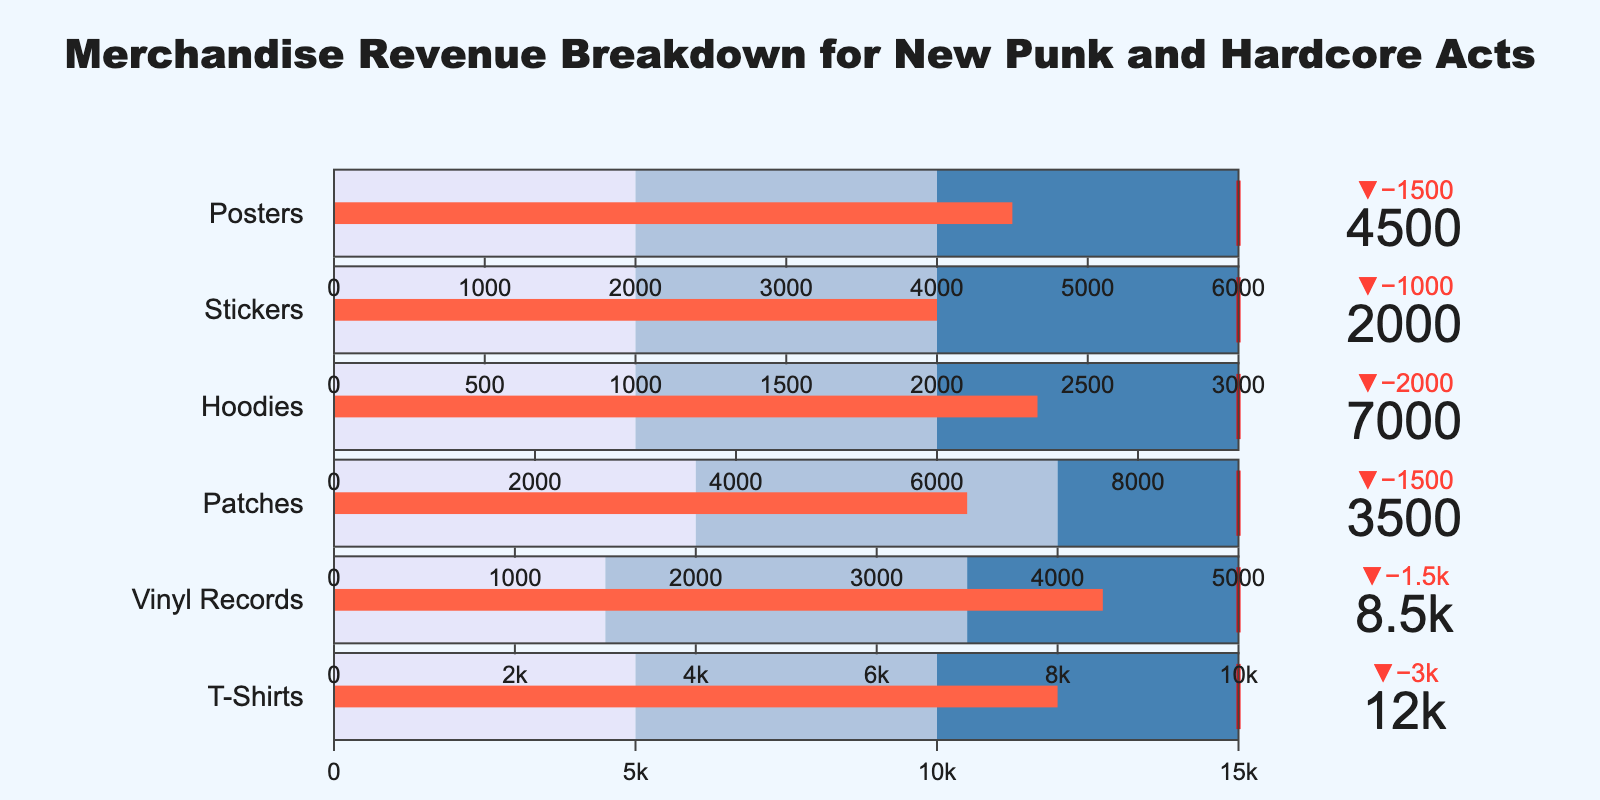What is the title of the figure? The title of the figure is typically placed at the top and is clearly visible. In this case, the title provides an overview of the figure's content.
Answer: Merchandise Revenue Breakdown for New Punk and Hardcore Acts How many revenue categories are there in the figure? To count the number of different categories, refer to the number of rows or groups represented visually in the bullet chart.
Answer: Six Which category has the highest actual revenue? By examining the actual revenue values presented in the bullet sections, we identify the one with the highest numerical value.
Answer: T-Shirts By how much did the actual revenue for Hoodies fall short of the target? Subtract the actual revenue from the target revenue to determine the shortfall. For Hoodies, it is calculated as 9000 (Target) - 7000 (Actual).
Answer: 2000 What color represents the best performance range in the bullet chart? The color for the best performance range is usually the one at the upper end of the scale. In this chart, the best performance range is highlighted distinctly.
Answer: Dark Blue Which two categories' actual revenues exactly match their lowest performance range? Compare the actual revenues with the defined performance ranges for each category. Categories where the actual revenue meets the lowest threshold are identified.
Answer: Stickers and Posters What is the total actual revenue for Vinyl Records and Hoodies combined? Add the actual revenues of Vinyl Records and Hoodies together. The calculation is 8500 (Vinyl Records) + 7000 (Hoodies).
Answer: 15500 Which category's actual revenue is closest to its target? Identify the category with the smallest difference between the actual and target revenues. This requires calculating the differences for all categories and comparing them.
Answer: Vinyl Records What is the median actual revenue of the categories? List the actual revenues in ascending order and identify the middle value. With six categories, the median is the average of the third and fourth values in the ordered list.
Answer: 5750 Which category has the largest discrepancy between its actual and target revenues? Calculate the discrepancies for each category by taking the absolute difference between the actual and target revenues, and identify the largest one.
Answer: T-Shirts 